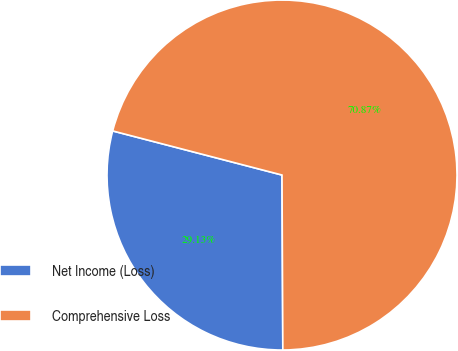<chart> <loc_0><loc_0><loc_500><loc_500><pie_chart><fcel>Net Income (Loss)<fcel>Comprehensive Loss<nl><fcel>29.13%<fcel>70.87%<nl></chart> 